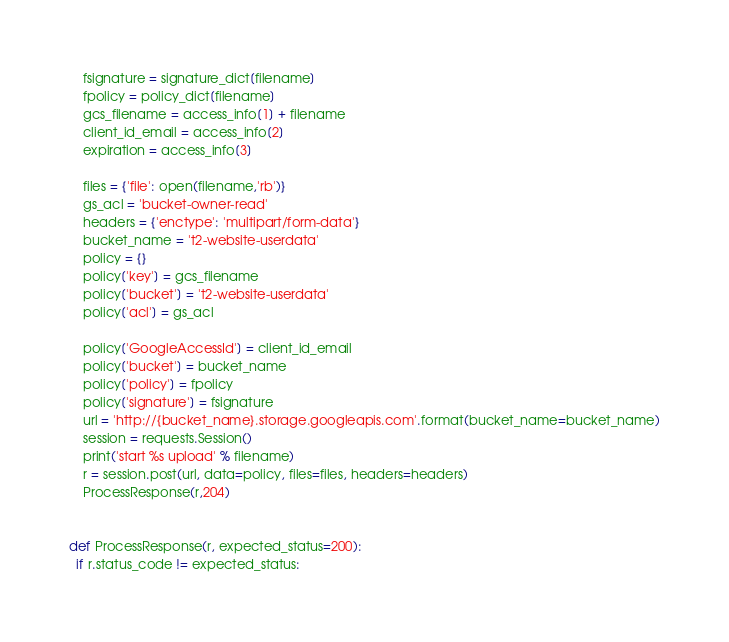<code> <loc_0><loc_0><loc_500><loc_500><_Python_>	fsignature = signature_dict[filename]
	fpolicy = policy_dict[filename]
	gcs_filename = access_info[1] + filename
	client_id_email = access_info[2]
	expiration = access_info[3]

	files = {'file': open(filename,'rb')}
	gs_acl = 'bucket-owner-read'
	headers = {'enctype': 'multipart/form-data'}
	bucket_name = 't2-website-userdata'
	policy = {}
	policy['key'] = gcs_filename
	policy['bucket'] = 't2-website-userdata'
	policy['acl'] = gs_acl

	policy['GoogleAccessId'] = client_id_email
	policy['bucket'] = bucket_name
	policy['policy'] = fpolicy
	policy['signature'] = fsignature
	url = 'http://{bucket_name}.storage.googleapis.com'.format(bucket_name=bucket_name)
	session = requests.Session()
	print('start %s upload' % filename)
	r = session.post(url, data=policy, files=files, headers=headers)
	ProcessResponse(r,204)


def ProcessResponse(r, expected_status=200):
  if r.status_code != expected_status:</code> 